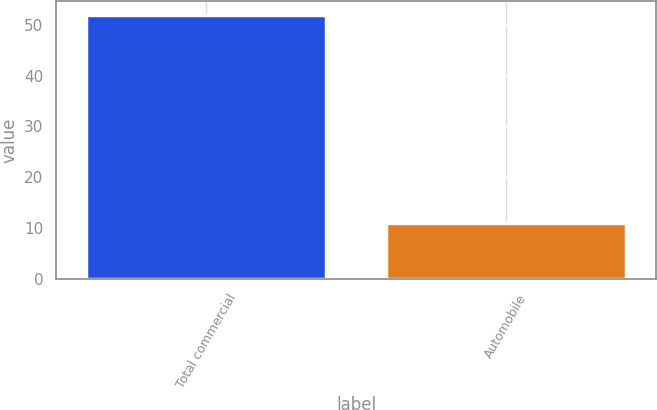<chart> <loc_0><loc_0><loc_500><loc_500><bar_chart><fcel>Total commercial<fcel>Automobile<nl><fcel>52<fcel>11<nl></chart> 